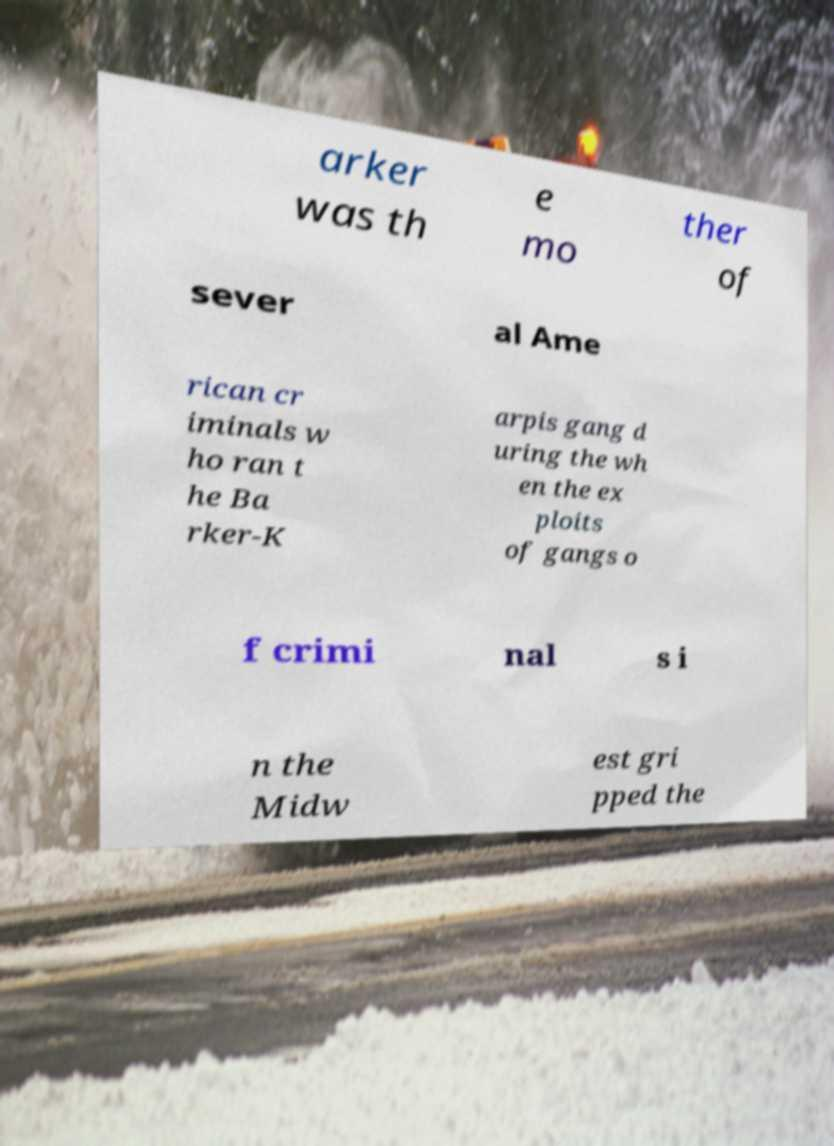There's text embedded in this image that I need extracted. Can you transcribe it verbatim? arker was th e mo ther of sever al Ame rican cr iminals w ho ran t he Ba rker-K arpis gang d uring the wh en the ex ploits of gangs o f crimi nal s i n the Midw est gri pped the 